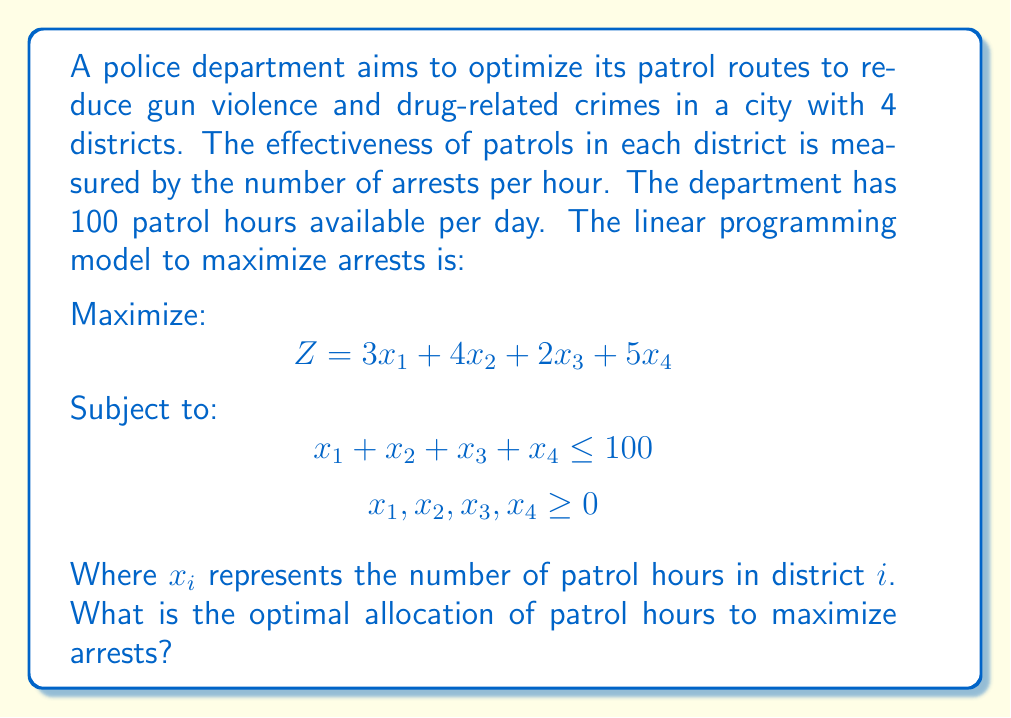Give your solution to this math problem. To solve this linear programming problem, we'll use the simplex method:

1) First, note that this is a standard maximization problem.

2) The objective function is already in standard form:
   $$ Z = 3x_1 + 4x_2 + 2x_3 + 5x_4 $$

3) We need to add a slack variable $s$ to convert the inequality constraint to an equality:
   $$ x_1 + x_2 + x_3 + x_4 + s = 100 $$

4) Our initial tableau is:

   $$ \begin{array}{c|cccc|c}
      & x_1 & x_2 & x_3 & x_4 & RHS \\
      \hline
      Z & -3 & -4 & -2 & -5 & 0 \\
      s & 1 & 1 & 1 & 1 & 100 \\
   \end{array} $$

5) The most negative entry in the Z-row is -5, corresponding to $x_4$. This becomes our pivot column.

6) Dividing the RHS by the pivot column entries: 100 / 1 = 100. This row becomes our pivot row.

7) Perform row operations to make the pivot element 1 and all other entries in the pivot column 0:

   $$ \begin{array}{c|cccc|c}
      & x_1 & x_2 & x_3 & x_4 & RHS \\
      \hline
      Z & 2 & 1 & 3 & 0 & 500 \\
      x_4 & 1 & 1 & 1 & 1 & 100 \\
   \end{array} $$

8) All entries in the Z-row are non-negative, so we've reached the optimal solution.

9) Reading from the tableau, we see that $x_4 = 100$ and all other variables are 0.

Therefore, the optimal allocation is to assign all 100 patrol hours to district 4.
Answer: Allocate all 100 patrol hours to district 4. 